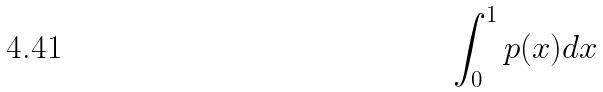<formula> <loc_0><loc_0><loc_500><loc_500>\int _ { 0 } ^ { 1 } p ( x ) d x</formula> 